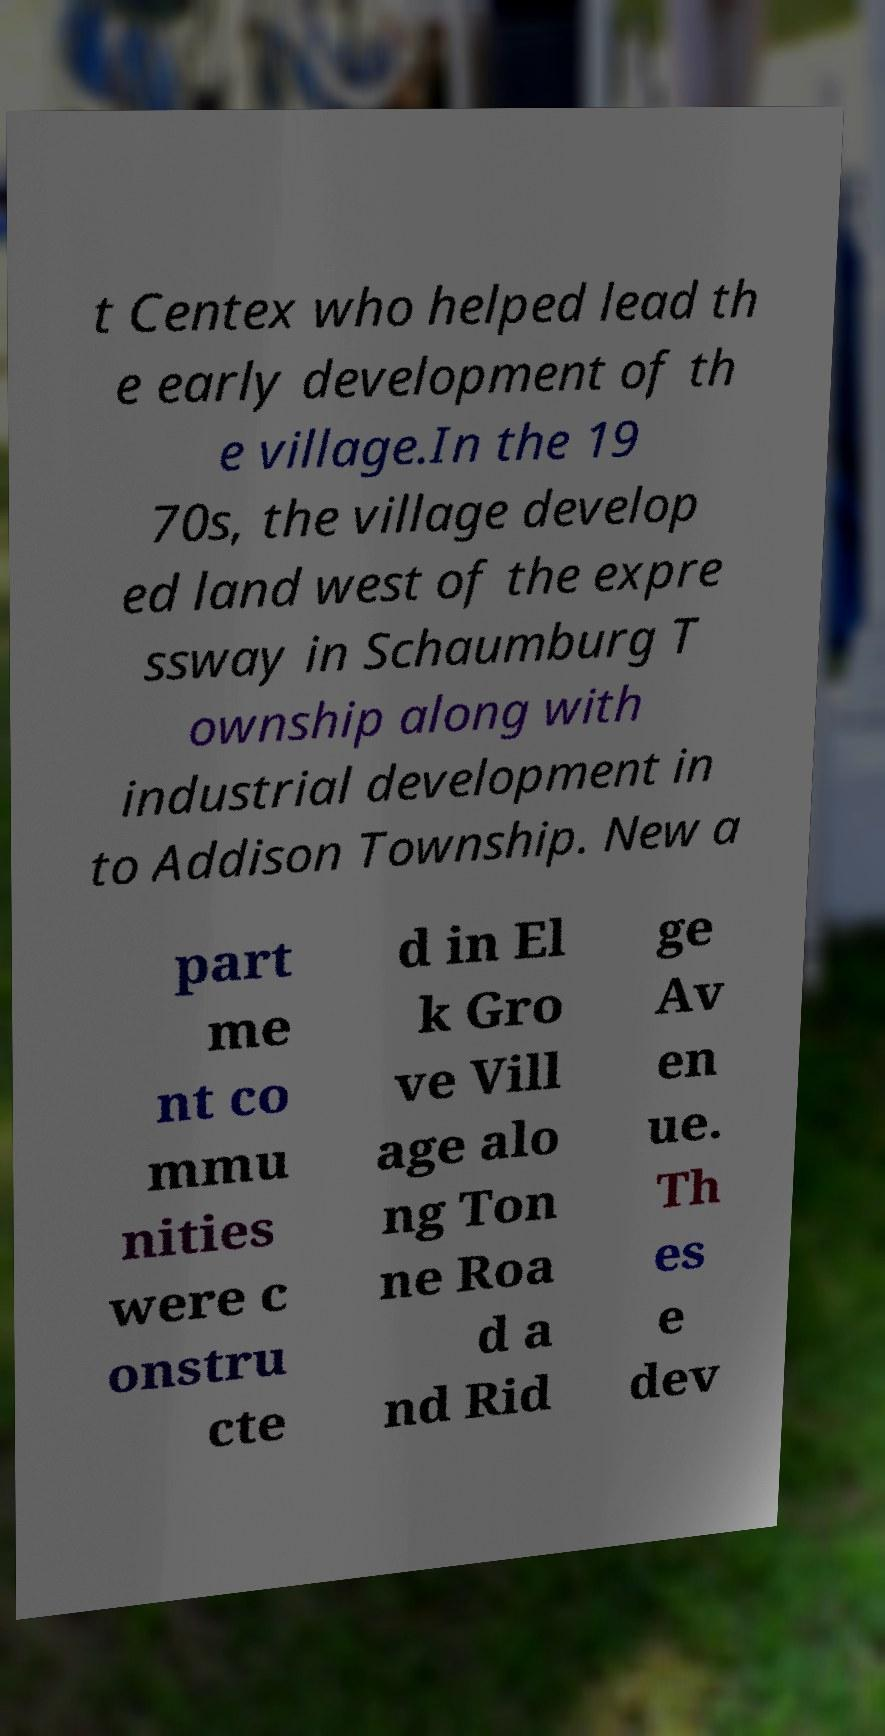Please read and relay the text visible in this image. What does it say? t Centex who helped lead th e early development of th e village.In the 19 70s, the village develop ed land west of the expre ssway in Schaumburg T ownship along with industrial development in to Addison Township. New a part me nt co mmu nities were c onstru cte d in El k Gro ve Vill age alo ng Ton ne Roa d a nd Rid ge Av en ue. Th es e dev 